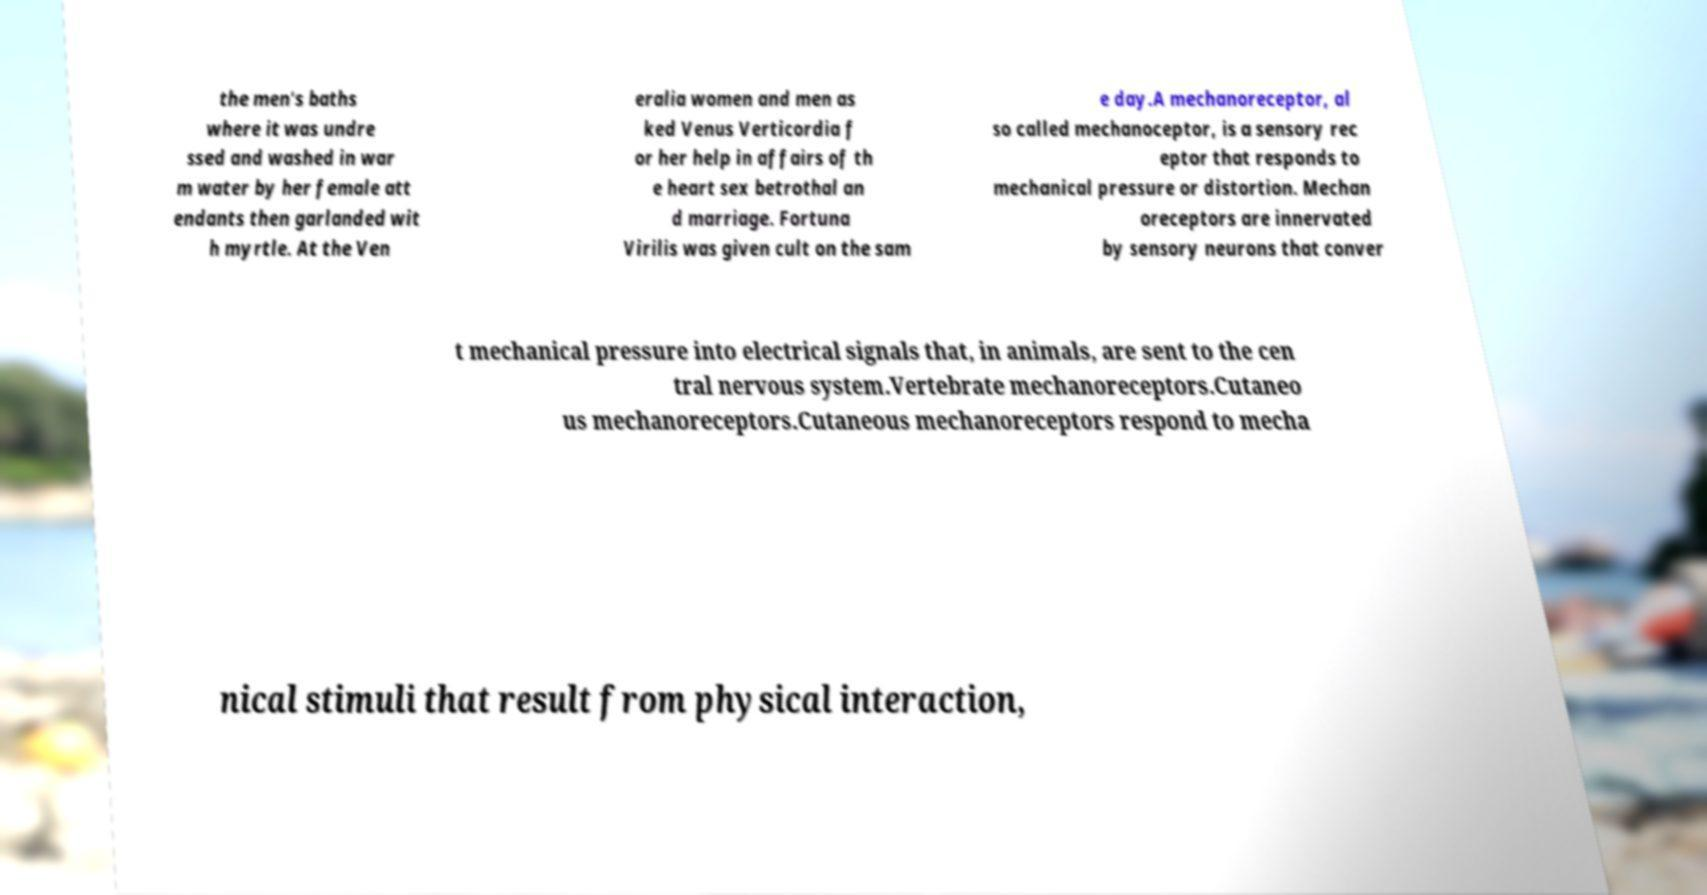Can you accurately transcribe the text from the provided image for me? the men's baths where it was undre ssed and washed in war m water by her female att endants then garlanded wit h myrtle. At the Ven eralia women and men as ked Venus Verticordia f or her help in affairs of th e heart sex betrothal an d marriage. Fortuna Virilis was given cult on the sam e day.A mechanoreceptor, al so called mechanoceptor, is a sensory rec eptor that responds to mechanical pressure or distortion. Mechan oreceptors are innervated by sensory neurons that conver t mechanical pressure into electrical signals that, in animals, are sent to the cen tral nervous system.Vertebrate mechanoreceptors.Cutaneo us mechanoreceptors.Cutaneous mechanoreceptors respond to mecha nical stimuli that result from physical interaction, 